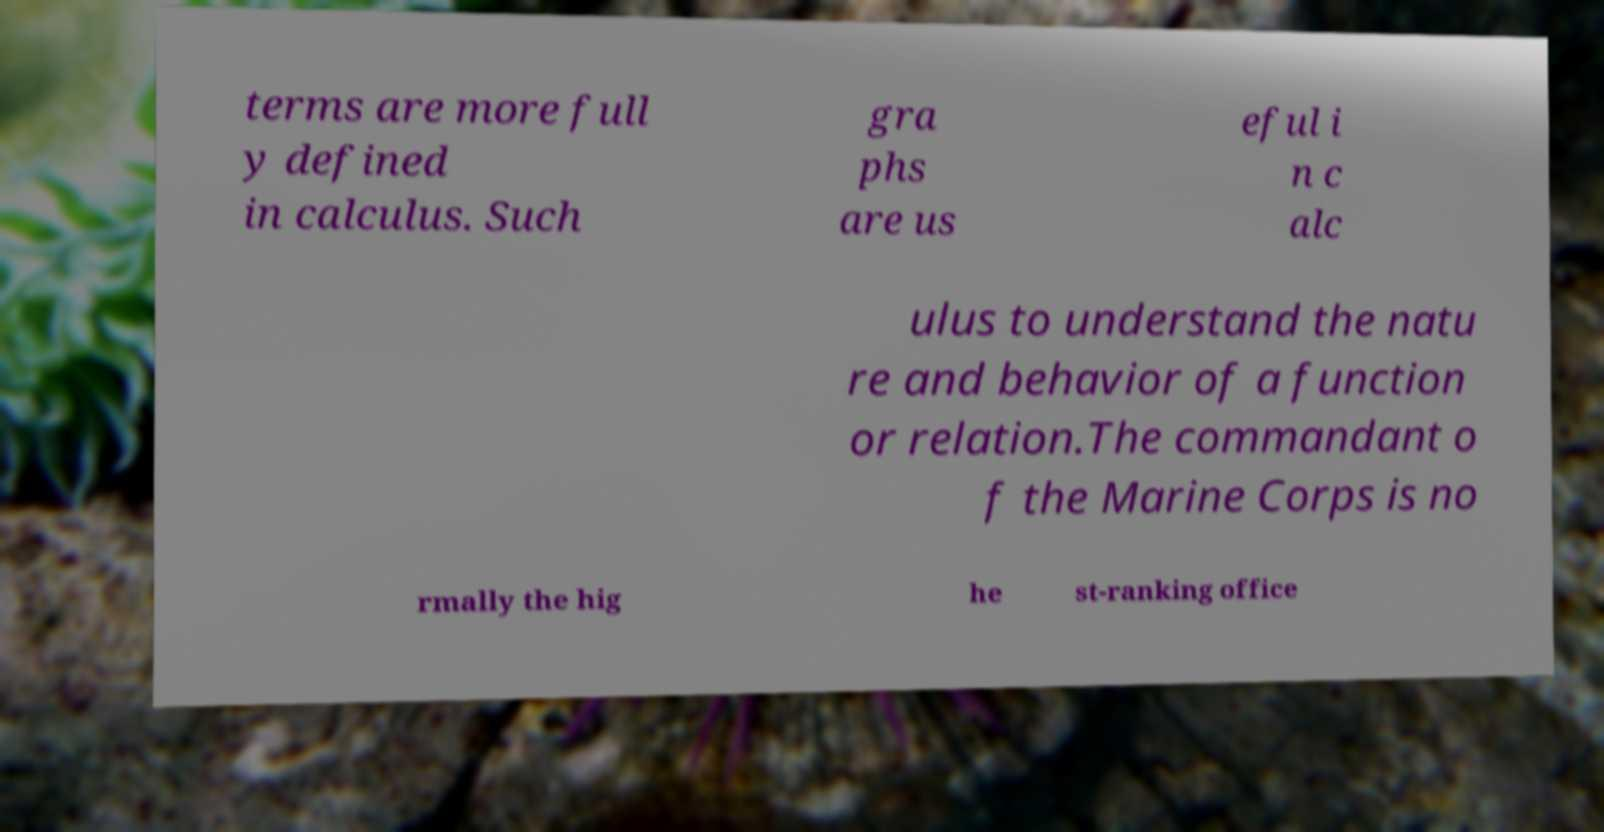Can you read and provide the text displayed in the image?This photo seems to have some interesting text. Can you extract and type it out for me? terms are more full y defined in calculus. Such gra phs are us eful i n c alc ulus to understand the natu re and behavior of a function or relation.The commandant o f the Marine Corps is no rmally the hig he st-ranking office 